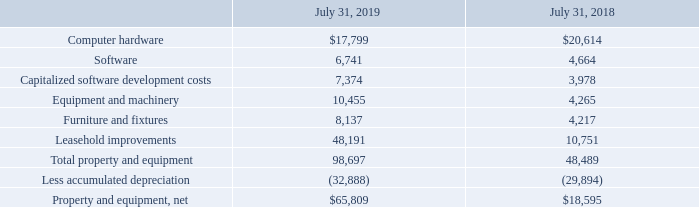Property and Equipment, net
Property and equipment consist of the following (in thousands):
As of July 31, 2019 and 2018, no property and equipment was pledged as collateral. Depreciation expense, excluding the amortization of software development costs, was $9.7 million, $7.7 million, and $6.6 million for the fiscal years ended July 31, 2019, 2018, and 2017, respectively.
The Company capitalizes software development costs for technology applications that the Company will offer solely as cloud-based subscriptions, which is primarily comprised of compensation for employees who are directly associated with the software development projects. The Company begins amortizing the capitalized software development costs once the technology applications are available for general release over the estimated lives of the applications, ranging from three to five years.
The Company recognized approximately $1.0 million and $0.4 million in amortization expense in cost of revenue - license and subscription on the accompanying consolidated statements of operations during the fiscal years ended July 31, 2019 and 2018, respectively. There was no such amortization during the fiscal year ended July 31, 2017.
What was the Depreciation expense, excluding the amortization of software development costs in 2019, 2018 and 2017 respectively? $9.7 million, $7.7 million, $6.6 million. What was the value of software in 2019?
Answer scale should be: thousand. 6,741. What was the value of Computer hardware in 2019?
Answer scale should be: thousand. $17,799. In which year was Computer hardware less than 20,000 thousands? Locate and analyze computer hardware in row 2
answer: 2019. What was the average Software value for 2018 and 2019?
Answer scale should be: thousand. (6,741 + 4,664) / 2
Answer: 5702.5. What was the change in the Capitalized software development costs from 2018 to 2019?
Answer scale should be: thousand. 7,374 - 3,978
Answer: 3396. 